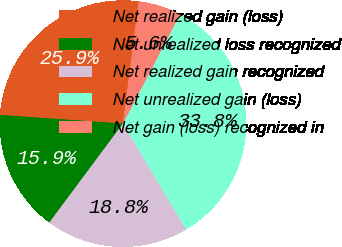<chart> <loc_0><loc_0><loc_500><loc_500><pie_chart><fcel>Net realized gain (loss)<fcel>Net unrealized loss recognized<fcel>Net realized gain recognized<fcel>Net unrealized gain (loss)<fcel>Net gain (loss) recognized in<nl><fcel>25.92%<fcel>15.94%<fcel>18.76%<fcel>33.77%<fcel>5.62%<nl></chart> 